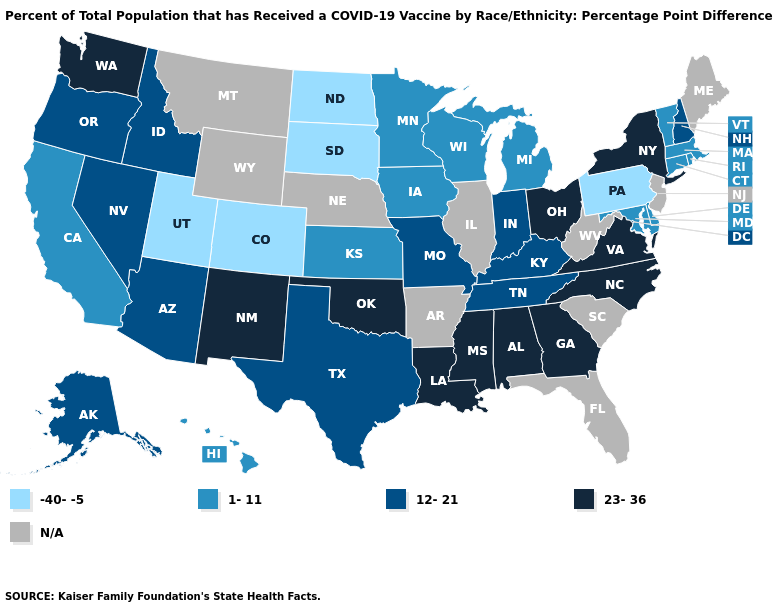What is the lowest value in states that border New Hampshire?
Short answer required. 1-11. Name the states that have a value in the range 12-21?
Concise answer only. Alaska, Arizona, Idaho, Indiana, Kentucky, Missouri, Nevada, New Hampshire, Oregon, Tennessee, Texas. What is the value of New Mexico?
Quick response, please. 23-36. Does the first symbol in the legend represent the smallest category?
Keep it brief. Yes. Name the states that have a value in the range 23-36?
Quick response, please. Alabama, Georgia, Louisiana, Mississippi, New Mexico, New York, North Carolina, Ohio, Oklahoma, Virginia, Washington. Which states have the lowest value in the USA?
Write a very short answer. Colorado, North Dakota, Pennsylvania, South Dakota, Utah. Does Mississippi have the highest value in the USA?
Quick response, please. Yes. Does North Dakota have the highest value in the USA?
Answer briefly. No. What is the highest value in the West ?
Give a very brief answer. 23-36. What is the highest value in states that border Virginia?
Quick response, please. 23-36. Among the states that border Delaware , does Pennsylvania have the highest value?
Write a very short answer. No. Does North Carolina have the lowest value in the South?
Short answer required. No. Name the states that have a value in the range 23-36?
Be succinct. Alabama, Georgia, Louisiana, Mississippi, New Mexico, New York, North Carolina, Ohio, Oklahoma, Virginia, Washington. 